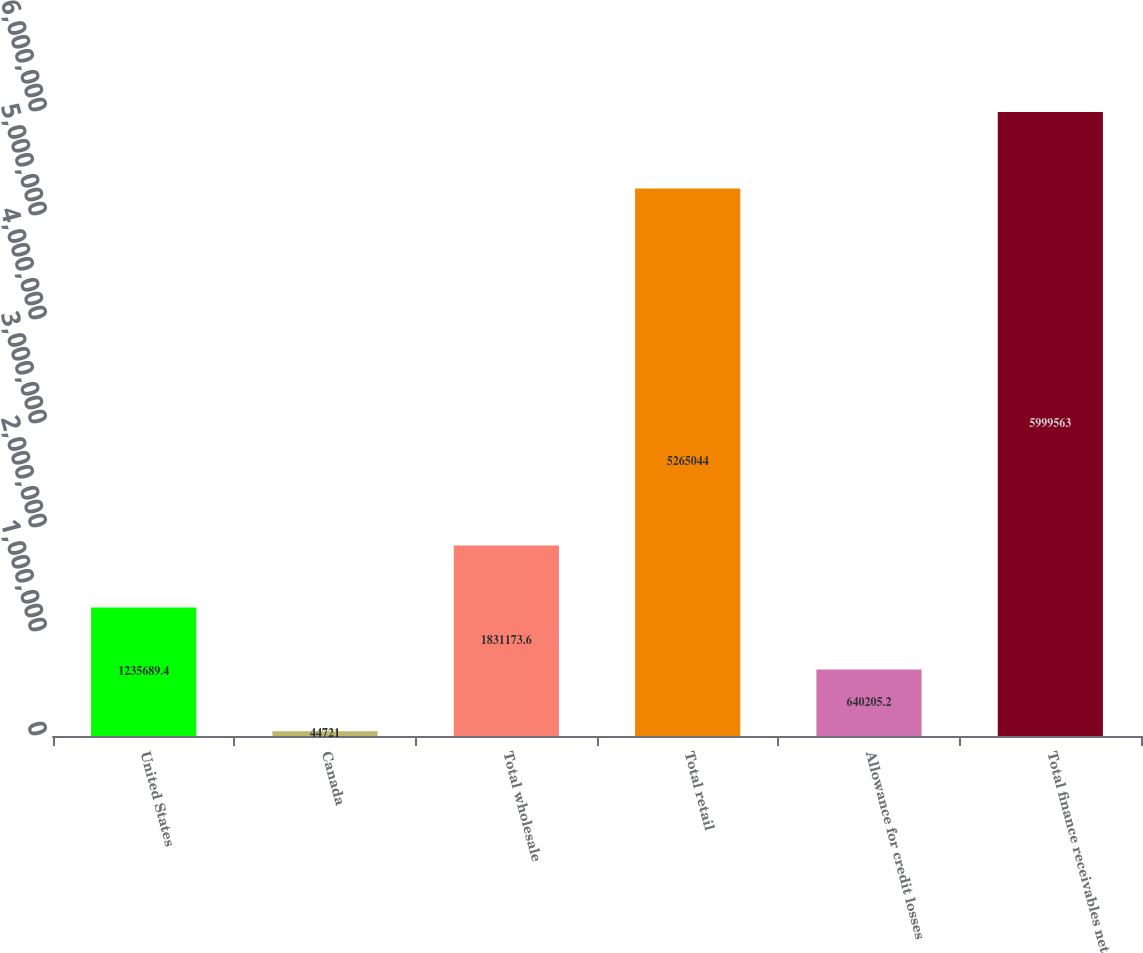Convert chart. <chart><loc_0><loc_0><loc_500><loc_500><bar_chart><fcel>United States<fcel>Canada<fcel>Total wholesale<fcel>Total retail<fcel>Allowance for credit losses<fcel>Total finance receivables net<nl><fcel>1.23569e+06<fcel>44721<fcel>1.83117e+06<fcel>5.26504e+06<fcel>640205<fcel>5.99956e+06<nl></chart> 